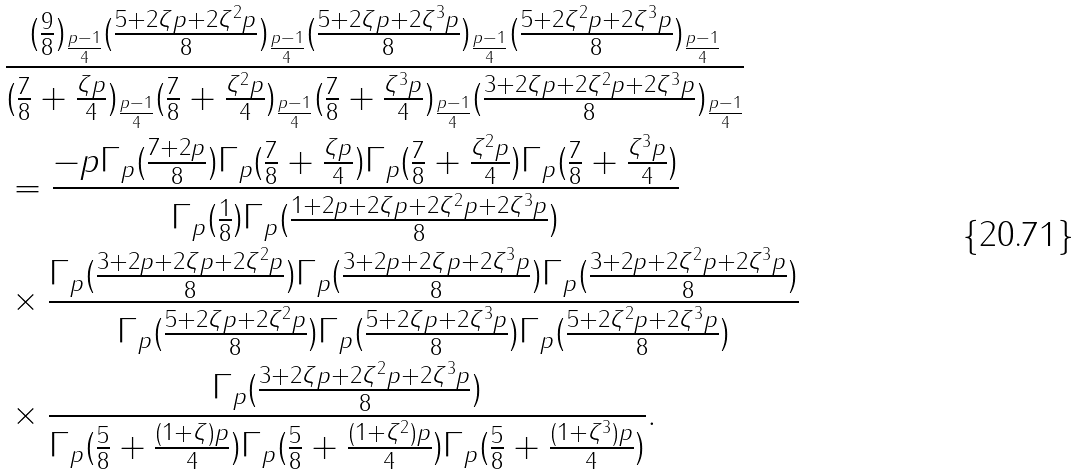<formula> <loc_0><loc_0><loc_500><loc_500>& \frac { ( \frac { 9 } { 8 } ) _ { \frac { p - 1 } { 4 } } ( \frac { 5 + 2 \zeta p + 2 \zeta ^ { 2 } p } { 8 } ) _ { \frac { p - 1 } { 4 } } ( \frac { 5 + 2 \zeta p + 2 \zeta ^ { 3 } p } { 8 } ) _ { \frac { p - 1 } { 4 } } ( \frac { 5 + 2 \zeta ^ { 2 } p + 2 \zeta ^ { 3 } p } { 8 } ) _ { \frac { p - 1 } { 4 } } } { ( \frac { 7 } { 8 } + \frac { \zeta p } { 4 } ) _ { \frac { p - 1 } { 4 } } ( \frac { 7 } { 8 } + \frac { \zeta ^ { 2 } p } { 4 } ) _ { \frac { p - 1 } { 4 } } ( \frac { 7 } { 8 } + \frac { \zeta ^ { 3 } p } { 4 } ) _ { \frac { p - 1 } { 4 } } ( \frac { 3 + 2 \zeta p + 2 \zeta ^ { 2 } p + 2 \zeta ^ { 3 } p } { 8 } ) _ { \frac { p - 1 } { 4 } } } \\ & = \frac { - p \Gamma _ { p } ( \frac { 7 + 2 p } { 8 } ) \Gamma _ { p } ( \frac { 7 } { 8 } + \frac { \zeta p } { 4 } ) \Gamma _ { p } ( \frac { 7 } { 8 } + \frac { \zeta ^ { 2 } p } { 4 } ) \Gamma _ { p } ( \frac { 7 } { 8 } + \frac { \zeta ^ { 3 } p } { 4 } ) } { \Gamma _ { p } ( \frac { 1 } { 8 } ) \Gamma _ { p } ( \frac { 1 + 2 p + 2 \zeta p + 2 \zeta ^ { 2 } p + 2 \zeta ^ { 3 } p } { 8 } ) } \\ & \times \frac { \Gamma _ { p } ( \frac { 3 + 2 p + 2 \zeta p + 2 \zeta ^ { 2 } p } { 8 } ) \Gamma _ { p } ( \frac { 3 + 2 p + 2 \zeta p + 2 \zeta ^ { 3 } p } { 8 } ) \Gamma _ { p } ( \frac { 3 + 2 p + 2 \zeta ^ { 2 } p + 2 \zeta ^ { 3 } p } { 8 } ) } { \Gamma _ { p } ( \frac { 5 + 2 \zeta p + 2 \zeta ^ { 2 } p } { 8 } ) \Gamma _ { p } ( \frac { 5 + 2 \zeta p + 2 \zeta ^ { 3 } p } { 8 } ) \Gamma _ { p } ( \frac { 5 + 2 \zeta ^ { 2 } p + 2 \zeta ^ { 3 } p } { 8 } ) } \\ & \times \frac { \Gamma _ { p } ( \frac { 3 + 2 \zeta p + 2 \zeta ^ { 2 } p + 2 \zeta ^ { 3 } p } { 8 } ) } { \Gamma _ { p } ( \frac { 5 } { 8 } + \frac { ( 1 + \zeta ) p } { 4 } ) \Gamma _ { p } ( \frac { 5 } { 8 } + \frac { ( 1 + \zeta ^ { 2 } ) p } { 4 } ) \Gamma _ { p } ( \frac { 5 } { 8 } + \frac { ( 1 + \zeta ^ { 3 } ) p } { 4 } ) } .</formula> 